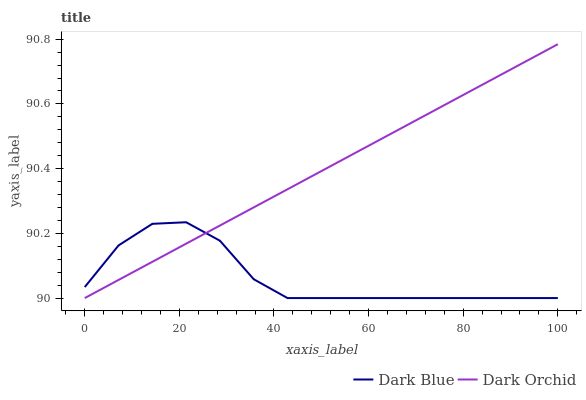Does Dark Blue have the minimum area under the curve?
Answer yes or no. Yes. Does Dark Orchid have the maximum area under the curve?
Answer yes or no. Yes. Does Dark Orchid have the minimum area under the curve?
Answer yes or no. No. Is Dark Orchid the smoothest?
Answer yes or no. Yes. Is Dark Blue the roughest?
Answer yes or no. Yes. Is Dark Orchid the roughest?
Answer yes or no. No. Does Dark Blue have the lowest value?
Answer yes or no. Yes. Does Dark Orchid have the highest value?
Answer yes or no. Yes. Does Dark Blue intersect Dark Orchid?
Answer yes or no. Yes. Is Dark Blue less than Dark Orchid?
Answer yes or no. No. Is Dark Blue greater than Dark Orchid?
Answer yes or no. No. 